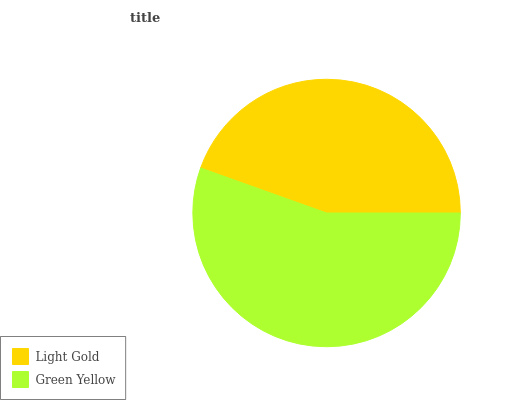Is Light Gold the minimum?
Answer yes or no. Yes. Is Green Yellow the maximum?
Answer yes or no. Yes. Is Green Yellow the minimum?
Answer yes or no. No. Is Green Yellow greater than Light Gold?
Answer yes or no. Yes. Is Light Gold less than Green Yellow?
Answer yes or no. Yes. Is Light Gold greater than Green Yellow?
Answer yes or no. No. Is Green Yellow less than Light Gold?
Answer yes or no. No. Is Green Yellow the high median?
Answer yes or no. Yes. Is Light Gold the low median?
Answer yes or no. Yes. Is Light Gold the high median?
Answer yes or no. No. Is Green Yellow the low median?
Answer yes or no. No. 